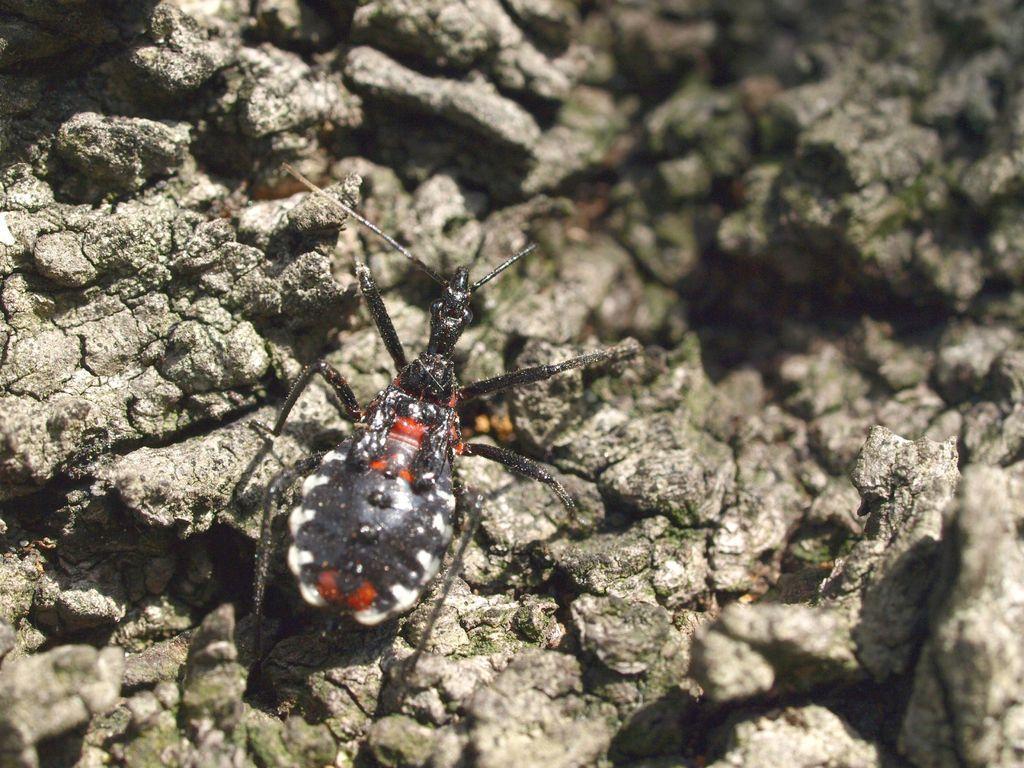Please provide a concise description of this image. In this image there is an insect on the rocky surface. 